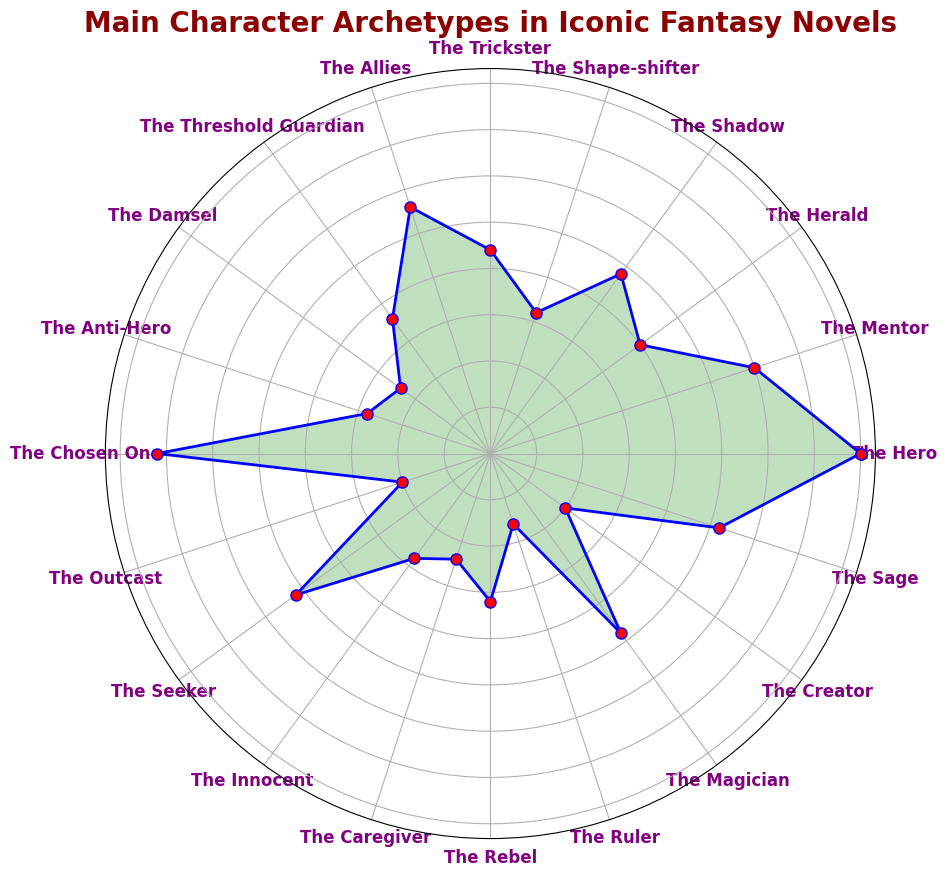What's the most common character archetype in iconic fantasy novels? By observing the highest point on the chart, we see that "The Hero" is the tallest, indicating it has the highest count.
Answer: The Hero Which character archetype has the lowest count? Looking at the shortest segment on the chart, we see that "The Ruler" is the smallest, indicating it has the lowest count.
Answer: The Ruler How does the count of "The Hero" compare to "The Chosen One"? Visually, "The Hero" and "The Chosen One" both have high counts, but "The Hero" appears slightly taller.
Answer: The Hero > The Chosen One What is the sum of counts for "The Hero" and "The Sage"? "The Hero" has a count of 20 and "The Sage" has a count of 13. Summing these counts gives us 20 + 13 = 33.
Answer: 33 Are there more "Mentor" archetypes or "Magician" archetypes? The chart shows that "The Mentor" has a count of 15 and "The Magician" has a count of 12.
Answer: Mentor > Magician What is the difference in counts between "The Hero" and "The Outcast"? "The Hero" has a count of 20, and "The Outcast" has a count of 5. The difference is 20 - 5 = 15.
Answer: 15 How many character archetypes have a single-digit count? By counting the segments with single-digit values, we see "The Threshold Guardian," "The Damsel," "The Anti-Hero," "The Outcast," "The Caregiver," "The Rebel," and "The Ruler." This sums to 7 archetypes.
Answer: 7 What's the average count of the archetypes "The Trickster," "The Allies," and "The Shape-shifter"? The counts are 11, 14, and 8 respectively. The average is (11 + 14 + 8) / 3 = 33 / 3 = 11.
Answer: 11 What is the combined count for "The Shadow" and "The Seeker"? "The Shadow" has a count of 12 and "The Seeker" has a count of 13. The combined count is 12 + 13 = 25.
Answer: 25 Which has a higher count: "The Anti-Hero" or "The Innocent"? The chart shows that both "The Anti-Hero" and "The Innocent" have a count of 7. Therefore, they are equal.
Answer: Equal 